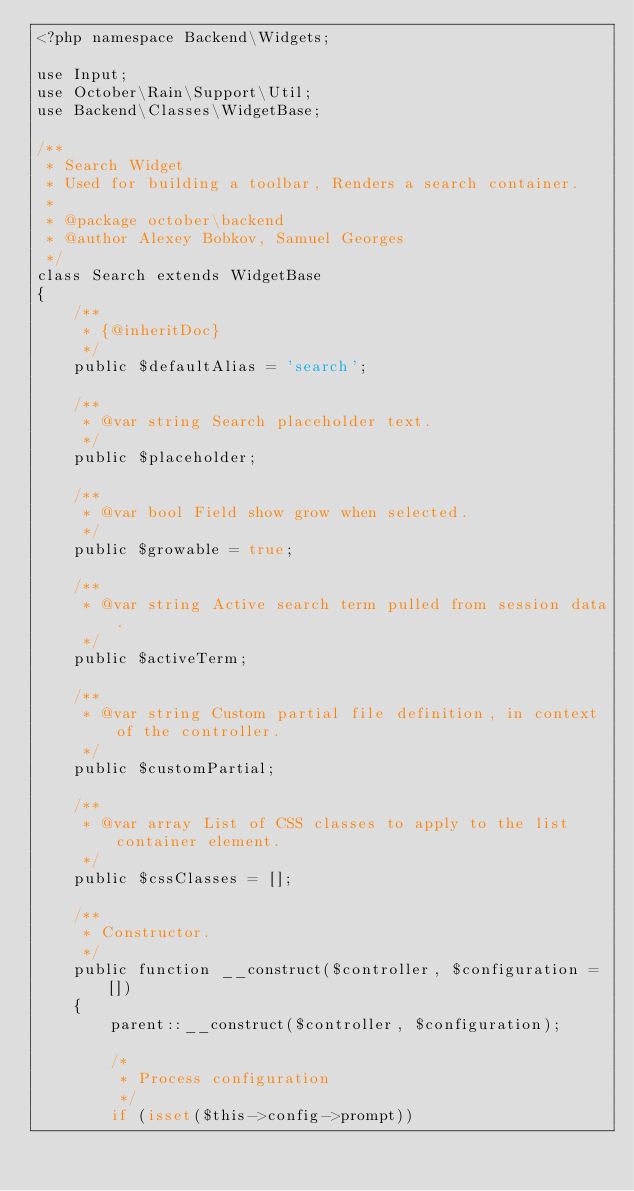<code> <loc_0><loc_0><loc_500><loc_500><_PHP_><?php namespace Backend\Widgets;

use Input;
use October\Rain\Support\Util;
use Backend\Classes\WidgetBase;

/**
 * Search Widget
 * Used for building a toolbar, Renders a search container.
 *
 * @package october\backend
 * @author Alexey Bobkov, Samuel Georges
 */
class Search extends WidgetBase
{
    /**
     * {@inheritDoc}
     */
    public $defaultAlias = 'search';

    /**
     * @var string Search placeholder text.
     */
    public $placeholder;

    /**
     * @var bool Field show grow when selected.
     */
    public $growable = true;

    /**
     * @var string Active search term pulled from session data.
     */
    public $activeTerm;

    /**
     * @var string Custom partial file definition, in context of the controller.
     */
    public $customPartial;

    /**
     * @var array List of CSS classes to apply to the list container element.
     */
    public $cssClasses = [];

    /**
     * Constructor.
     */
    public function __construct($controller, $configuration = [])
    {
        parent::__construct($controller, $configuration);

        /*
         * Process configuration
         */
        if (isset($this->config->prompt))</code> 